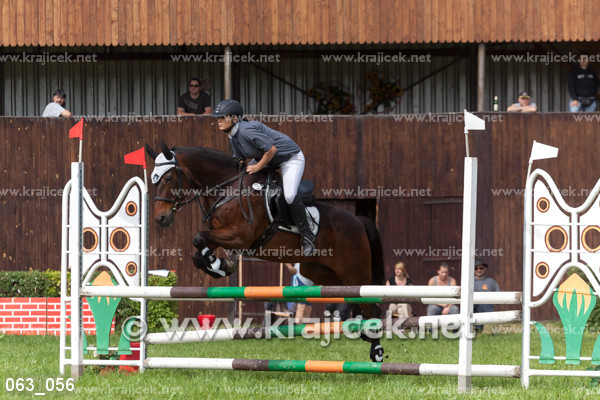What are some key elements a judge might be looking for in this competition? Judges in show jumping competitions typically look for a few key elements: the horse's form as it clears the fences, the rider's posture and control, the fluidity and speed of the course run, and most importantly, that the team avoids knocking down any bars or refusing a jump. 